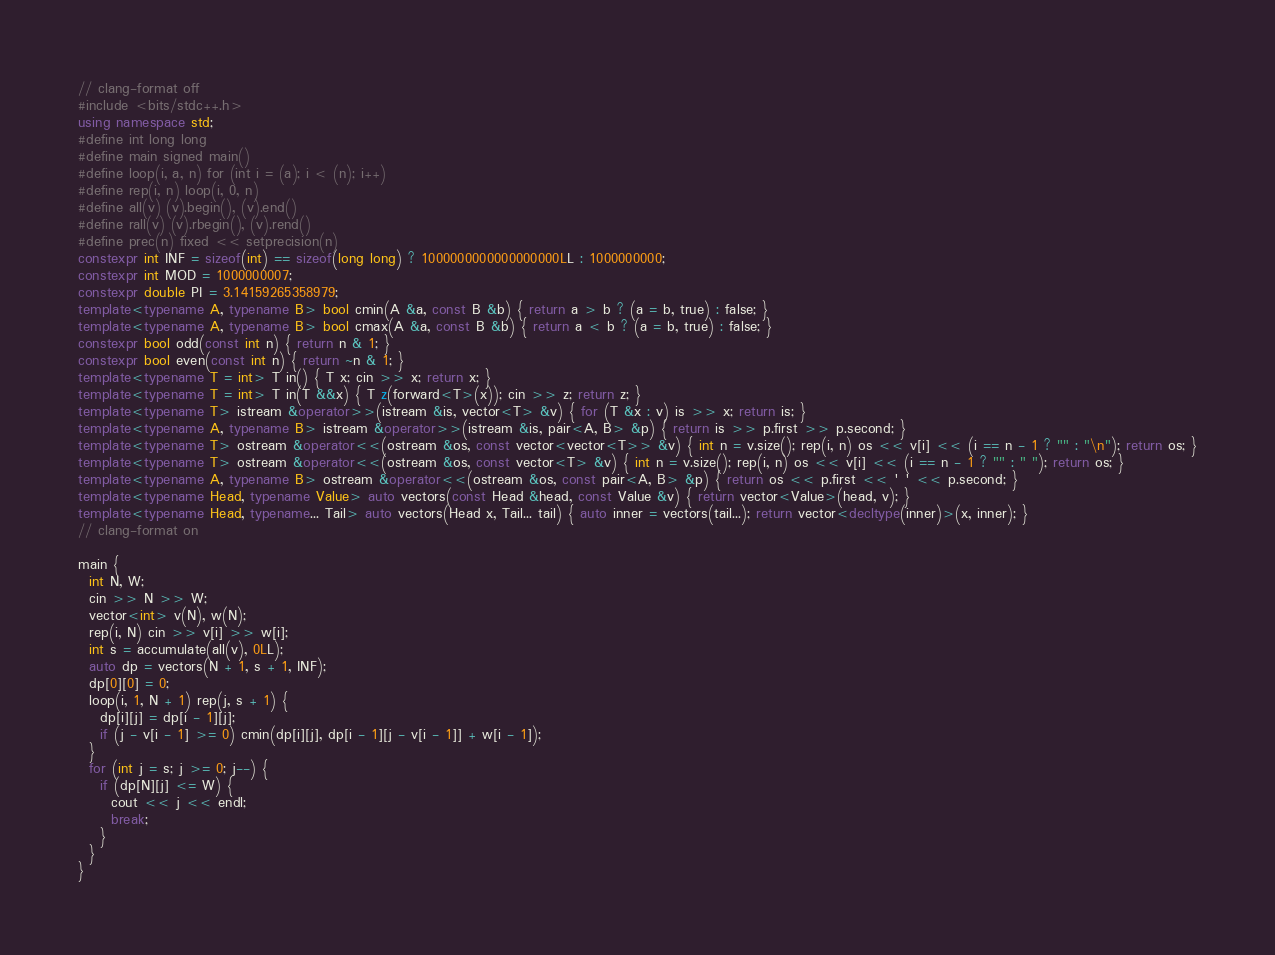<code> <loc_0><loc_0><loc_500><loc_500><_C++_>// clang-format off
#include <bits/stdc++.h>
using namespace std;
#define int long long
#define main signed main()
#define loop(i, a, n) for (int i = (a); i < (n); i++)
#define rep(i, n) loop(i, 0, n)
#define all(v) (v).begin(), (v).end()
#define rall(v) (v).rbegin(), (v).rend()
#define prec(n) fixed << setprecision(n)
constexpr int INF = sizeof(int) == sizeof(long long) ? 1000000000000000000LL : 1000000000;
constexpr int MOD = 1000000007;
constexpr double PI = 3.14159265358979;
template<typename A, typename B> bool cmin(A &a, const B &b) { return a > b ? (a = b, true) : false; }
template<typename A, typename B> bool cmax(A &a, const B &b) { return a < b ? (a = b, true) : false; }
constexpr bool odd(const int n) { return n & 1; }
constexpr bool even(const int n) { return ~n & 1; }
template<typename T = int> T in() { T x; cin >> x; return x; }
template<typename T = int> T in(T &&x) { T z(forward<T>(x)); cin >> z; return z; }
template<typename T> istream &operator>>(istream &is, vector<T> &v) { for (T &x : v) is >> x; return is; }
template<typename A, typename B> istream &operator>>(istream &is, pair<A, B> &p) { return is >> p.first >> p.second; }
template<typename T> ostream &operator<<(ostream &os, const vector<vector<T>> &v) { int n = v.size(); rep(i, n) os << v[i] << (i == n - 1 ? "" : "\n"); return os; }
template<typename T> ostream &operator<<(ostream &os, const vector<T> &v) { int n = v.size(); rep(i, n) os << v[i] << (i == n - 1 ? "" : " "); return os; }
template<typename A, typename B> ostream &operator<<(ostream &os, const pair<A, B> &p) { return os << p.first << ' ' << p.second; }
template<typename Head, typename Value> auto vectors(const Head &head, const Value &v) { return vector<Value>(head, v); }
template<typename Head, typename... Tail> auto vectors(Head x, Tail... tail) { auto inner = vectors(tail...); return vector<decltype(inner)>(x, inner); }
// clang-format on

main {
  int N, W;
  cin >> N >> W;
  vector<int> v(N), w(N);
  rep(i, N) cin >> v[i] >> w[i];
  int s = accumulate(all(v), 0LL);
  auto dp = vectors(N + 1, s + 1, INF);
  dp[0][0] = 0;
  loop(i, 1, N + 1) rep(j, s + 1) {
    dp[i][j] = dp[i - 1][j];
    if (j - v[i - 1] >= 0) cmin(dp[i][j], dp[i - 1][j - v[i - 1]] + w[i - 1]);
  }
  for (int j = s; j >= 0; j--) {
    if (dp[N][j] <= W) {
      cout << j << endl;
      break;
    }
  }
}

</code> 